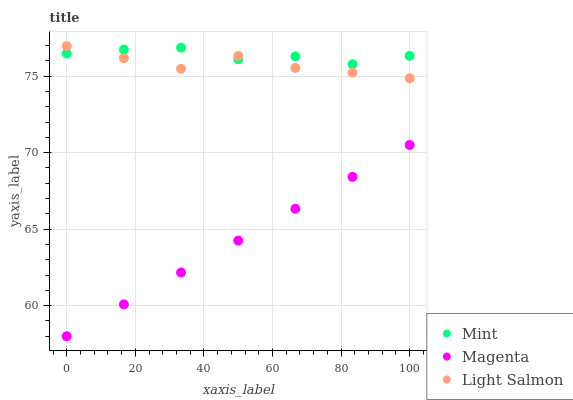Does Magenta have the minimum area under the curve?
Answer yes or no. Yes. Does Mint have the maximum area under the curve?
Answer yes or no. Yes. Does Light Salmon have the minimum area under the curve?
Answer yes or no. No. Does Light Salmon have the maximum area under the curve?
Answer yes or no. No. Is Magenta the smoothest?
Answer yes or no. Yes. Is Light Salmon the roughest?
Answer yes or no. Yes. Is Mint the smoothest?
Answer yes or no. No. Is Mint the roughest?
Answer yes or no. No. Does Magenta have the lowest value?
Answer yes or no. Yes. Does Light Salmon have the lowest value?
Answer yes or no. No. Does Light Salmon have the highest value?
Answer yes or no. Yes. Does Mint have the highest value?
Answer yes or no. No. Is Magenta less than Light Salmon?
Answer yes or no. Yes. Is Light Salmon greater than Magenta?
Answer yes or no. Yes. Does Light Salmon intersect Mint?
Answer yes or no. Yes. Is Light Salmon less than Mint?
Answer yes or no. No. Is Light Salmon greater than Mint?
Answer yes or no. No. Does Magenta intersect Light Salmon?
Answer yes or no. No. 